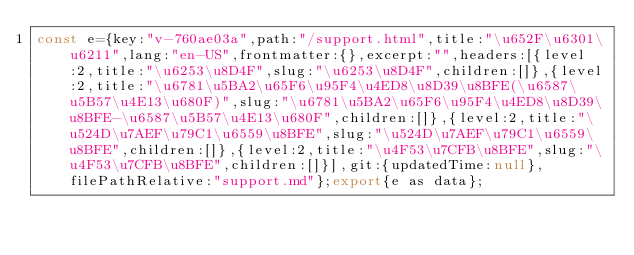<code> <loc_0><loc_0><loc_500><loc_500><_JavaScript_>const e={key:"v-760ae03a",path:"/support.html",title:"\u652F\u6301\u6211",lang:"en-US",frontmatter:{},excerpt:"",headers:[{level:2,title:"\u6253\u8D4F",slug:"\u6253\u8D4F",children:[]},{level:2,title:"\u6781\u5BA2\u65F6\u95F4\u4ED8\u8D39\u8BFE(\u6587\u5B57\u4E13\u680F)",slug:"\u6781\u5BA2\u65F6\u95F4\u4ED8\u8D39\u8BFE-\u6587\u5B57\u4E13\u680F",children:[]},{level:2,title:"\u524D\u7AEF\u79C1\u6559\u8BFE",slug:"\u524D\u7AEF\u79C1\u6559\u8BFE",children:[]},{level:2,title:"\u4F53\u7CFB\u8BFE",slug:"\u4F53\u7CFB\u8BFE",children:[]}],git:{updatedTime:null},filePathRelative:"support.md"};export{e as data};
</code> 